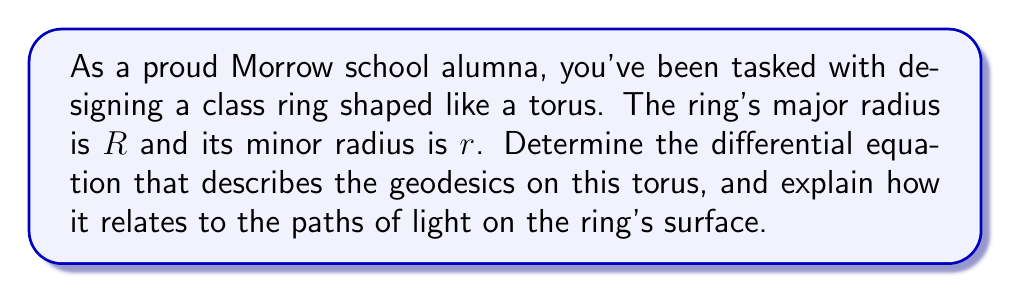Help me with this question. To determine the geodesics on a torus, we'll follow these steps:

1) First, we need to parameterize the torus. Let's use the standard parameterization:
   $$x = (R + r\cos\phi)\cos\theta$$
   $$y = (R + r\cos\phi)\sin\theta$$
   $$z = r\sin\phi$$
   where $0 \leq \theta < 2\pi$ and $0 \leq \phi < 2\pi$.

2) Next, we need to calculate the metric tensor. The components are:
   $$g_{11} = (R + r\cos\phi)^2$$
   $$g_{12} = g_{21} = 0$$
   $$g_{22} = r^2$$

3) The geodesic equations are given by:
   $$\frac{d^2x^i}{ds^2} + \Gamma^i_{jk}\frac{dx^j}{ds}\frac{dx^k}{ds} = 0$$
   where $\Gamma^i_{jk}$ are the Christoffel symbols.

4) Calculating the non-zero Christoffel symbols:
   $$\Gamma^1_{11} = \frac{r\sin\phi}{R + r\cos\phi}$$
   $$\Gamma^1_{22} = -\frac{R + r\cos\phi}{r}$$
   $$\Gamma^2_{12} = \Gamma^2_{21} = \frac{1}{R + r\cos\phi}$$

5) Substituting these into the geodesic equations:
   $$\frac{d^2\theta}{ds^2} + \frac{2r\sin\phi}{R + r\cos\phi}\frac{d\theta}{ds}\frac{d\phi}{ds} = 0$$
   $$\frac{d^2\phi}{ds^2} - (R + r\cos\phi)\sin\phi\left(\frac{d\theta}{ds}\right)^2 = 0$$

6) These equations describe the geodesics on the torus. They represent the paths that light would follow on the surface of the ring, as light always travels along geodesics.

7) The solutions to these equations can be classified into three types:
   a) Circles around the tube (when $\frac{d\theta}{ds} = 0$)
   b) Circles around the central axis (when $\phi = constant$)
   c) Spirals that wind around the torus (in all other cases)

These geodesics represent the possible paths that light could take on the surface of the class ring, symbolizing the various journeys and connections of Morrow school alumni.
Answer: $$\frac{d^2\theta}{ds^2} + \frac{2r\sin\phi}{R + r\cos\phi}\frac{d\theta}{ds}\frac{d\phi}{ds} = 0$$
$$\frac{d^2\phi}{ds^2} - (R + r\cos\phi)\sin\phi\left(\frac{d\theta}{ds}\right)^2 = 0$$ 